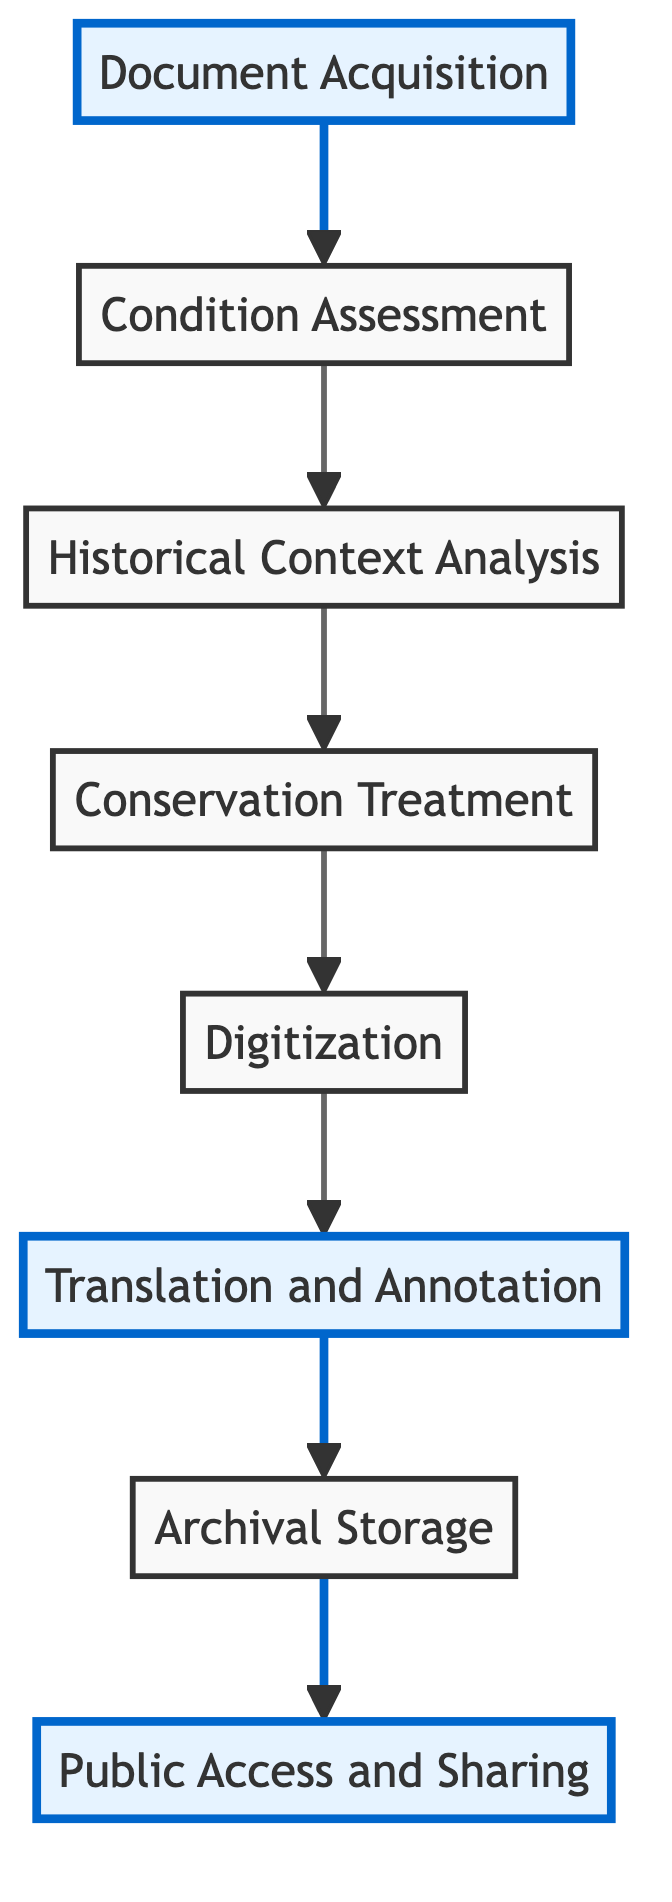What is the first step in the preservation workflow? The first step in the workflow is "Document Acquisition." This is indicated as the starting node that flows up to the next step in the diagram.
Answer: Document Acquisition How many steps are there in total? The total number of steps can be counted by noting each unique node in the flowchart, which includes Document Acquisition, Condition Assessment, Historical Context Analysis, Conservation Treatment, Digitization, Translation and Annotation, Archival Storage, and Public Access and Sharing. This gives a total of eight steps.
Answer: 8 What is the final action in the workflow? The final action in the workflow is "Public Access and Sharing." This is the last node in the flow from bottom to up, showing the end goal of the workflow.
Answer: Public Access and Sharing Which two steps directly follow "Condition Assessment"? The two steps that follow "Condition Assessment" are "Historical Context Analysis" and "Conservation Treatment." The flowchart shows a direct upward progression from Condition Assessment to these two nodes.
Answer: Historical Context Analysis, Conservation Treatment What step is highlighted that involves using technology? The highlighted step that involves using technology is "Digitization." In the diagram, this node is visually emphasized to indicate its importance in the workflow.
Answer: Digitization What is the relationship between "Translation and Annotation" and "Archival Storage"? The relationship is that "Translation and Annotation" directly leads to "Archival Storage." After translating and annotating the documents, they are then stored in the archival facilities, as shown in the diagram.
Answer: Directly leads to Which two steps must be completed before accessing the public? The two steps that must be completed before accessing the public are "Archival Storage" and "Translation and Annotation." Both must be completed for the documents to be ready for public access, as represented by their positions in the flowchart.
Answer: Archival Storage, Translation and Annotation What kind of documents are focused on in this workflow? The workflow focuses on "rare documents." This description is part of the title and thematic intent of the workflow, addressing the process of preserving documents that are uncommon or valuable historically.
Answer: Rare documents 